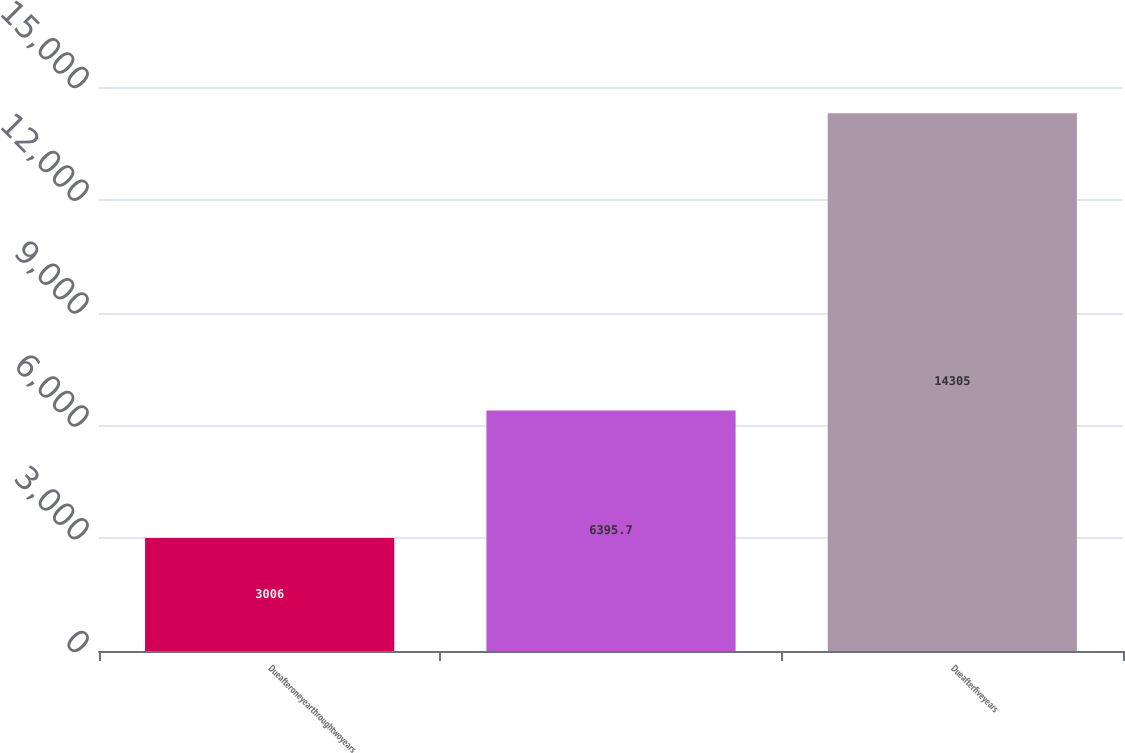<chart> <loc_0><loc_0><loc_500><loc_500><bar_chart><fcel>Dueafteroneyearthroughtwoyears<fcel>Unnamed: 1<fcel>Dueafterfiveyears<nl><fcel>3006<fcel>6395.7<fcel>14305<nl></chart> 